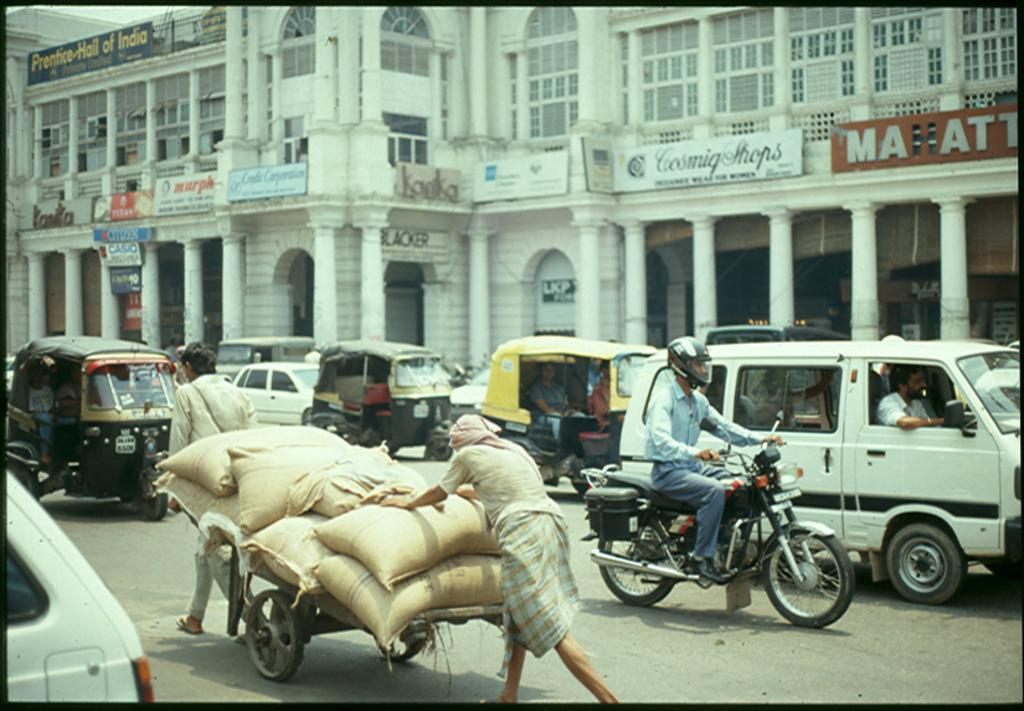How many people are in the image? There is a group of people in the image. What are two persons doing in the image? Two persons are carrying a load on a vehicle. What can be seen in the background of the image? There is a building in the background of the image. What type of coach can be seen in the alley in the image? There is no coach or alley present in the image. 